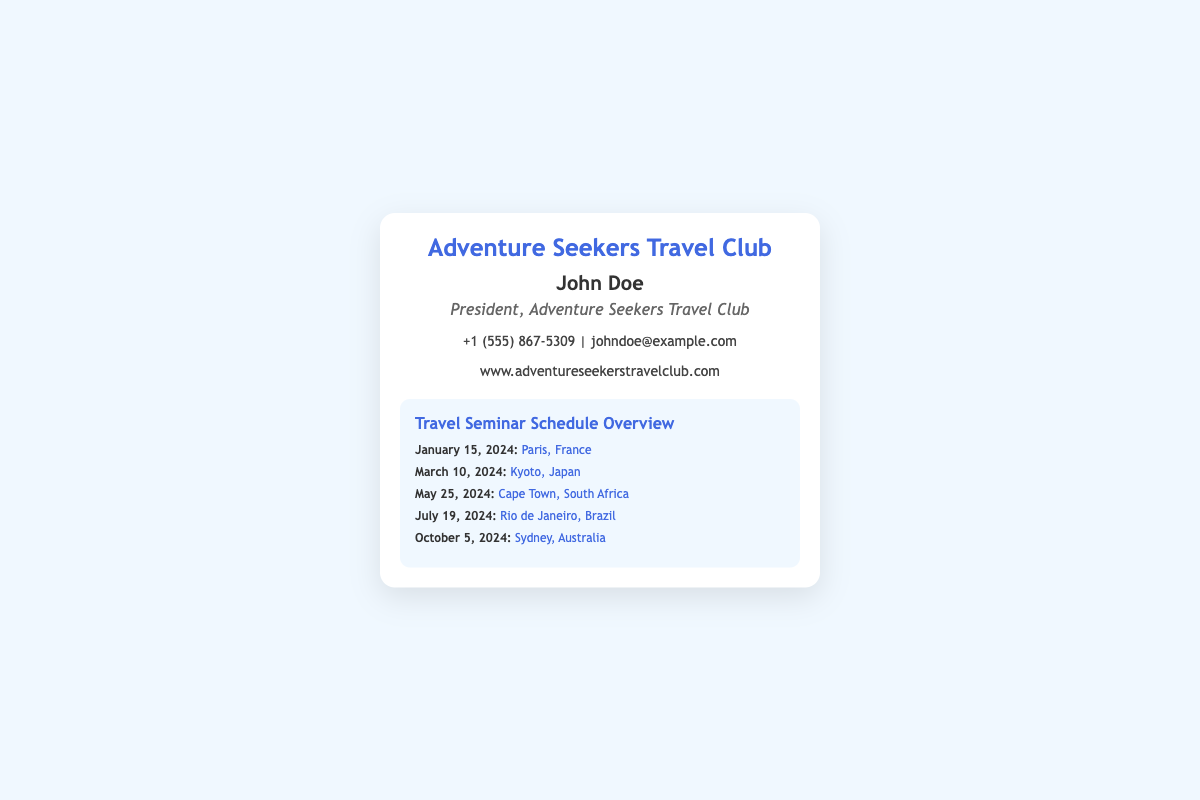what is the name of the club? The name of the club is displayed at the top of the business card.
Answer: Adventure Seekers Travel Club who is the president of the club? The president's name is presented prominently on the card.
Answer: John Doe what is the date of the seminar in Paris? The date for the Paris seminar is clearly mentioned in the schedule.
Answer: January 15, 2024 which country will the seminar in March be held? The country for the March seminar is specified in the schedule.
Answer: Japan how many destinations are listed in the seminar schedule? The number of destinations is counted from the schedule provided.
Answer: Five what is the focus of the travel club's events? The focus is evident from the title of the seminar section on the card.
Answer: Educational travel seminars when is the last seminar scheduled in 2024? The last seminar date is indicated in the schedule provided.
Answer: October 5, 2024 which destination is highlighted for the seminar on July 19? The specific destination for that date is mentioned in the items.
Answer: Rio de Janeiro, Brazil what is the contact email for the president? The email address is presented in the contact info section.
Answer: johndoe@example.com 